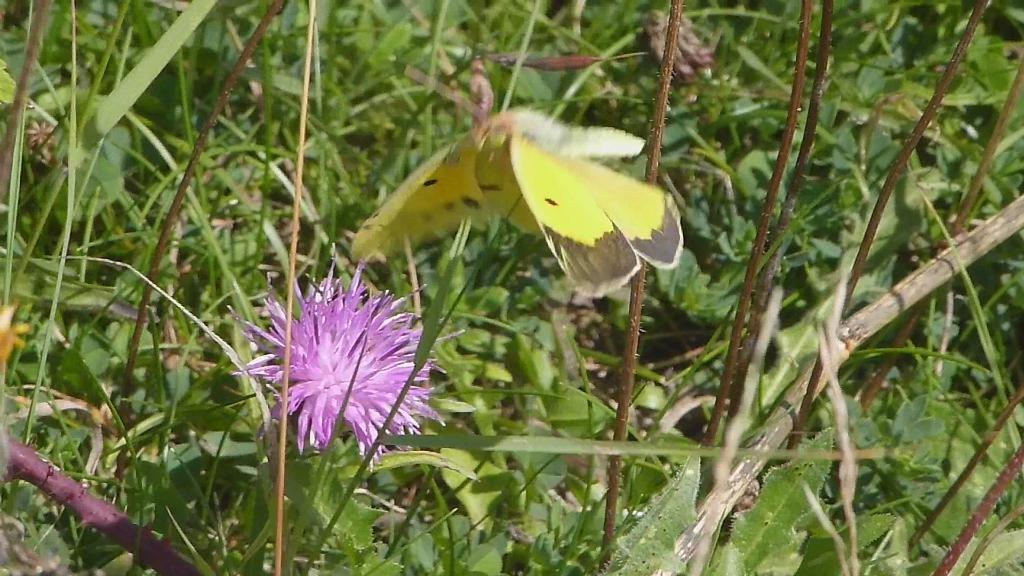What is the main subject in the center of the image? There is a butterfly in the center of the image. What can be seen in the foreground of the image? There is a flower on the stem of a plant in the foreground. What is visible in the background of the image? There is a group of plants in the background. Where is the basin located in the image? There is no basin present in the image. What type of rifle is being used by the butterfly in the image? There is no rifle present in the image, as it features a butterfly and plants. 